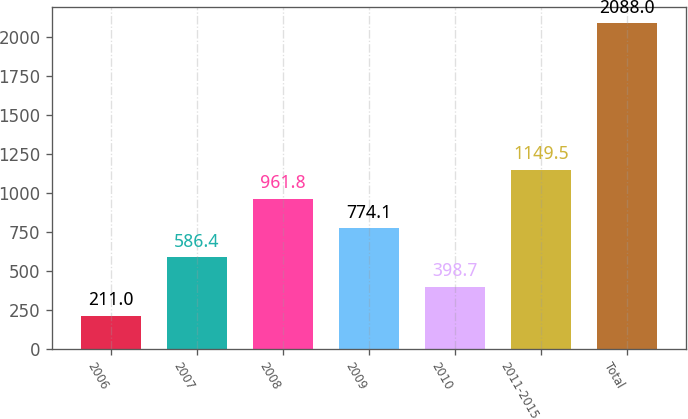Convert chart to OTSL. <chart><loc_0><loc_0><loc_500><loc_500><bar_chart><fcel>2006<fcel>2007<fcel>2008<fcel>2009<fcel>2010<fcel>2011-2015<fcel>Total<nl><fcel>211<fcel>586.4<fcel>961.8<fcel>774.1<fcel>398.7<fcel>1149.5<fcel>2088<nl></chart> 